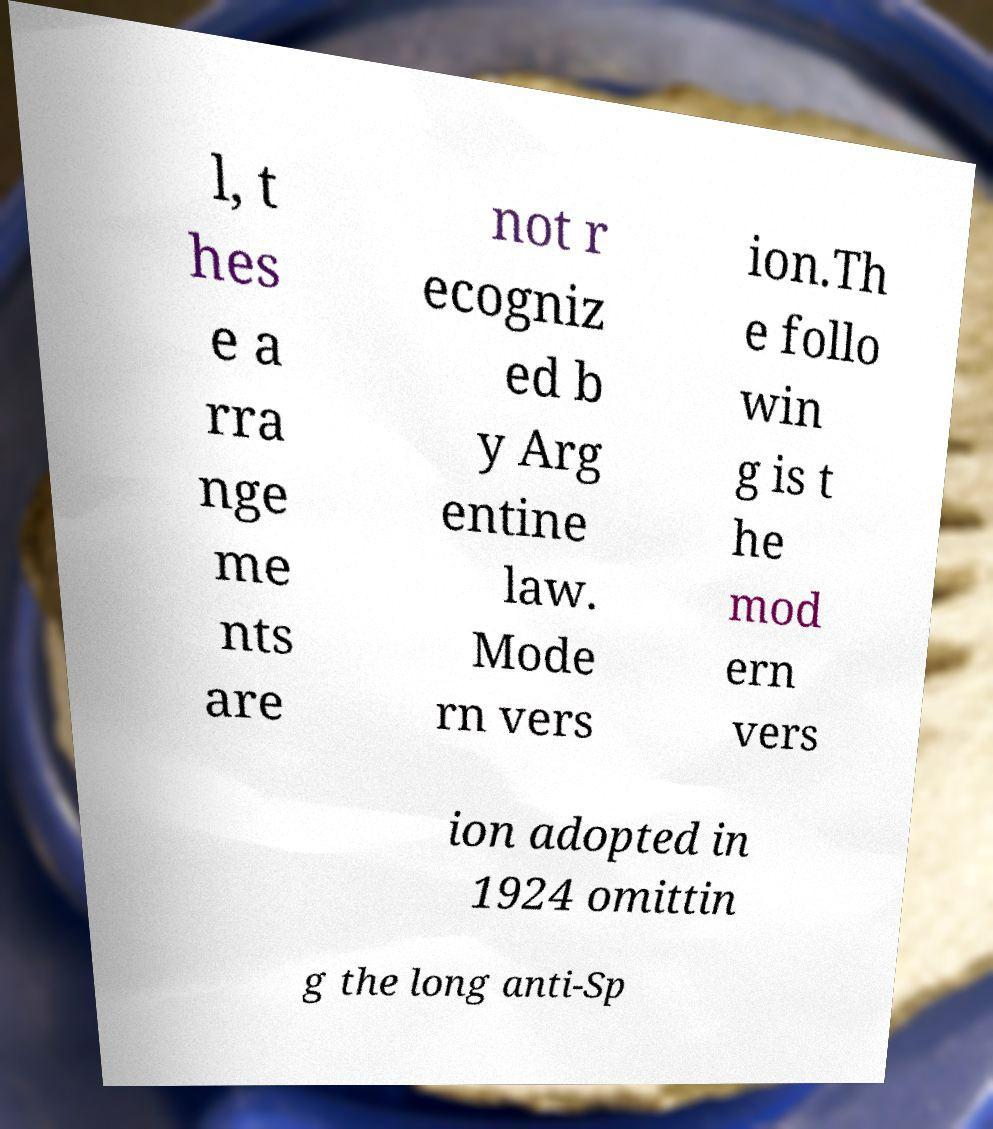Please identify and transcribe the text found in this image. l, t hes e a rra nge me nts are not r ecogniz ed b y Arg entine law. Mode rn vers ion.Th e follo win g is t he mod ern vers ion adopted in 1924 omittin g the long anti-Sp 